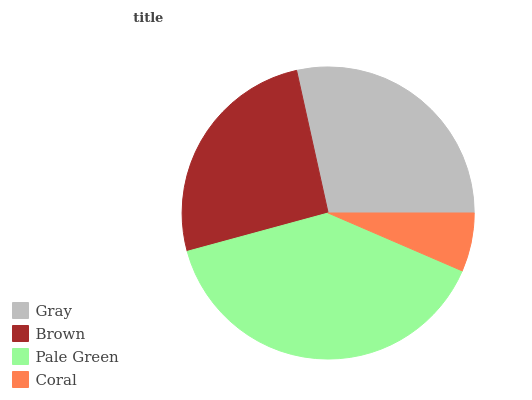Is Coral the minimum?
Answer yes or no. Yes. Is Pale Green the maximum?
Answer yes or no. Yes. Is Brown the minimum?
Answer yes or no. No. Is Brown the maximum?
Answer yes or no. No. Is Gray greater than Brown?
Answer yes or no. Yes. Is Brown less than Gray?
Answer yes or no. Yes. Is Brown greater than Gray?
Answer yes or no. No. Is Gray less than Brown?
Answer yes or no. No. Is Gray the high median?
Answer yes or no. Yes. Is Brown the low median?
Answer yes or no. Yes. Is Pale Green the high median?
Answer yes or no. No. Is Pale Green the low median?
Answer yes or no. No. 